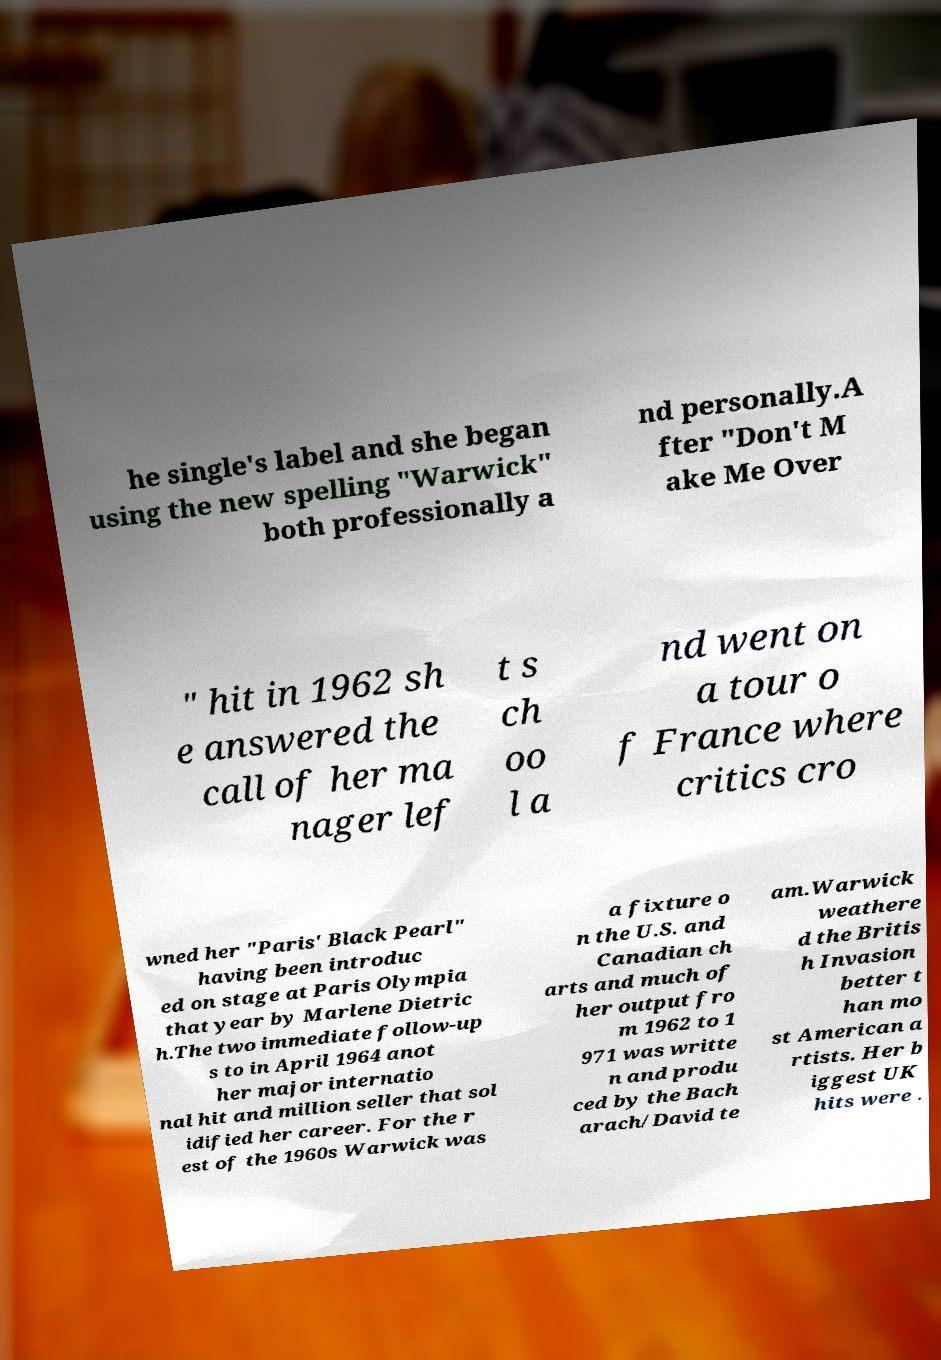Please identify and transcribe the text found in this image. he single's label and she began using the new spelling "Warwick" both professionally a nd personally.A fter "Don't M ake Me Over " hit in 1962 sh e answered the call of her ma nager lef t s ch oo l a nd went on a tour o f France where critics cro wned her "Paris' Black Pearl" having been introduc ed on stage at Paris Olympia that year by Marlene Dietric h.The two immediate follow-up s to in April 1964 anot her major internatio nal hit and million seller that sol idified her career. For the r est of the 1960s Warwick was a fixture o n the U.S. and Canadian ch arts and much of her output fro m 1962 to 1 971 was writte n and produ ced by the Bach arach/David te am.Warwick weathere d the Britis h Invasion better t han mo st American a rtists. Her b iggest UK hits were . 